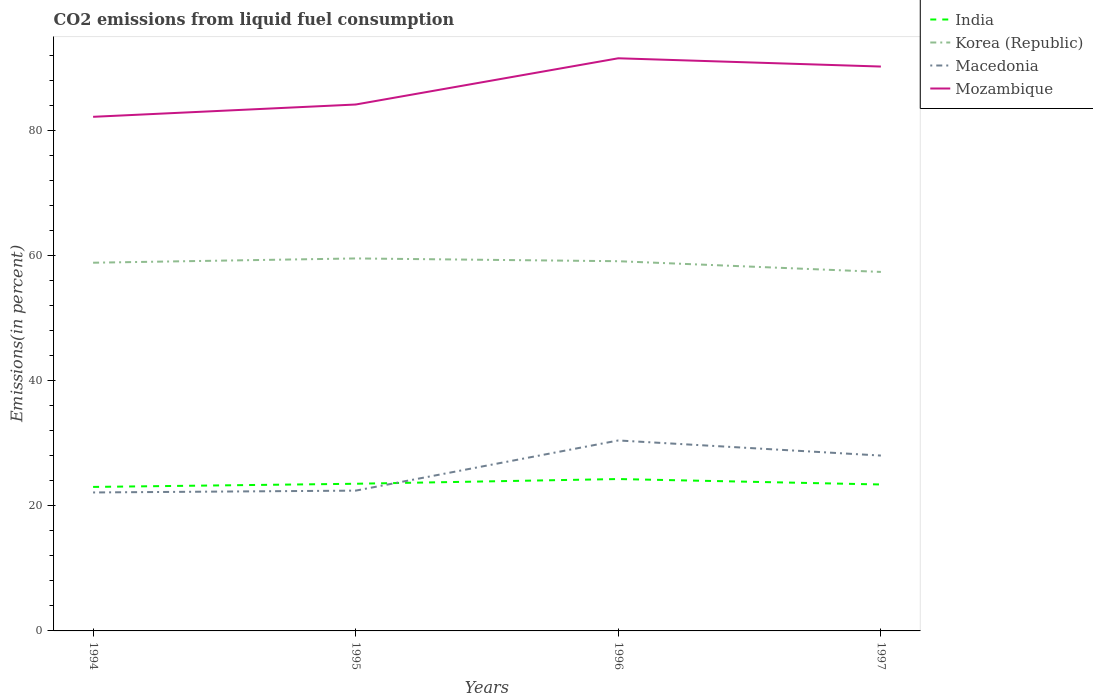Does the line corresponding to Macedonia intersect with the line corresponding to Korea (Republic)?
Offer a very short reply. No. Across all years, what is the maximum total CO2 emitted in Korea (Republic)?
Offer a very short reply. 57.39. What is the total total CO2 emitted in India in the graph?
Offer a terse response. -1.26. What is the difference between the highest and the second highest total CO2 emitted in Mozambique?
Offer a very short reply. 9.36. How many lines are there?
Keep it short and to the point. 4. Where does the legend appear in the graph?
Provide a short and direct response. Top right. What is the title of the graph?
Your answer should be very brief. CO2 emissions from liquid fuel consumption. What is the label or title of the X-axis?
Provide a succinct answer. Years. What is the label or title of the Y-axis?
Provide a succinct answer. Emissions(in percent). What is the Emissions(in percent) in India in 1994?
Provide a succinct answer. 23.02. What is the Emissions(in percent) in Korea (Republic) in 1994?
Offer a very short reply. 58.87. What is the Emissions(in percent) of Macedonia in 1994?
Offer a very short reply. 22.14. What is the Emissions(in percent) of Mozambique in 1994?
Your response must be concise. 82.19. What is the Emissions(in percent) of India in 1995?
Make the answer very short. 23.53. What is the Emissions(in percent) in Korea (Republic) in 1995?
Make the answer very short. 59.55. What is the Emissions(in percent) in Macedonia in 1995?
Your response must be concise. 22.43. What is the Emissions(in percent) of Mozambique in 1995?
Provide a succinct answer. 84.16. What is the Emissions(in percent) in India in 1996?
Your answer should be compact. 24.28. What is the Emissions(in percent) of Korea (Republic) in 1996?
Your answer should be compact. 59.11. What is the Emissions(in percent) in Macedonia in 1996?
Your response must be concise. 30.45. What is the Emissions(in percent) of Mozambique in 1996?
Keep it short and to the point. 91.55. What is the Emissions(in percent) in India in 1997?
Make the answer very short. 23.41. What is the Emissions(in percent) of Korea (Republic) in 1997?
Your answer should be very brief. 57.39. What is the Emissions(in percent) of Macedonia in 1997?
Ensure brevity in your answer.  28.03. What is the Emissions(in percent) in Mozambique in 1997?
Give a very brief answer. 90.23. Across all years, what is the maximum Emissions(in percent) in India?
Your response must be concise. 24.28. Across all years, what is the maximum Emissions(in percent) in Korea (Republic)?
Your answer should be very brief. 59.55. Across all years, what is the maximum Emissions(in percent) of Macedonia?
Your answer should be very brief. 30.45. Across all years, what is the maximum Emissions(in percent) in Mozambique?
Provide a short and direct response. 91.55. Across all years, what is the minimum Emissions(in percent) of India?
Provide a short and direct response. 23.02. Across all years, what is the minimum Emissions(in percent) of Korea (Republic)?
Offer a very short reply. 57.39. Across all years, what is the minimum Emissions(in percent) of Macedonia?
Offer a terse response. 22.14. Across all years, what is the minimum Emissions(in percent) in Mozambique?
Your answer should be compact. 82.19. What is the total Emissions(in percent) of India in the graph?
Make the answer very short. 94.24. What is the total Emissions(in percent) in Korea (Republic) in the graph?
Provide a short and direct response. 234.92. What is the total Emissions(in percent) in Macedonia in the graph?
Your response must be concise. 103.05. What is the total Emissions(in percent) in Mozambique in the graph?
Give a very brief answer. 348.13. What is the difference between the Emissions(in percent) of India in 1994 and that in 1995?
Make the answer very short. -0.51. What is the difference between the Emissions(in percent) in Korea (Republic) in 1994 and that in 1995?
Provide a succinct answer. -0.68. What is the difference between the Emissions(in percent) in Macedonia in 1994 and that in 1995?
Ensure brevity in your answer.  -0.29. What is the difference between the Emissions(in percent) in Mozambique in 1994 and that in 1995?
Keep it short and to the point. -1.97. What is the difference between the Emissions(in percent) in India in 1994 and that in 1996?
Your response must be concise. -1.26. What is the difference between the Emissions(in percent) of Korea (Republic) in 1994 and that in 1996?
Offer a terse response. -0.24. What is the difference between the Emissions(in percent) of Macedonia in 1994 and that in 1996?
Ensure brevity in your answer.  -8.31. What is the difference between the Emissions(in percent) in Mozambique in 1994 and that in 1996?
Offer a very short reply. -9.36. What is the difference between the Emissions(in percent) of India in 1994 and that in 1997?
Offer a terse response. -0.39. What is the difference between the Emissions(in percent) in Korea (Republic) in 1994 and that in 1997?
Your answer should be very brief. 1.47. What is the difference between the Emissions(in percent) of Macedonia in 1994 and that in 1997?
Offer a terse response. -5.9. What is the difference between the Emissions(in percent) of Mozambique in 1994 and that in 1997?
Your response must be concise. -8.04. What is the difference between the Emissions(in percent) in India in 1995 and that in 1996?
Your response must be concise. -0.76. What is the difference between the Emissions(in percent) in Korea (Republic) in 1995 and that in 1996?
Your answer should be compact. 0.44. What is the difference between the Emissions(in percent) of Macedonia in 1995 and that in 1996?
Your answer should be compact. -8.02. What is the difference between the Emissions(in percent) of Mozambique in 1995 and that in 1996?
Offer a terse response. -7.39. What is the difference between the Emissions(in percent) of India in 1995 and that in 1997?
Ensure brevity in your answer.  0.12. What is the difference between the Emissions(in percent) of Korea (Republic) in 1995 and that in 1997?
Keep it short and to the point. 2.16. What is the difference between the Emissions(in percent) of Macedonia in 1995 and that in 1997?
Provide a succinct answer. -5.61. What is the difference between the Emissions(in percent) of Mozambique in 1995 and that in 1997?
Your answer should be compact. -6.07. What is the difference between the Emissions(in percent) of India in 1996 and that in 1997?
Your answer should be compact. 0.87. What is the difference between the Emissions(in percent) of Korea (Republic) in 1996 and that in 1997?
Offer a very short reply. 1.71. What is the difference between the Emissions(in percent) of Macedonia in 1996 and that in 1997?
Your response must be concise. 2.42. What is the difference between the Emissions(in percent) of Mozambique in 1996 and that in 1997?
Your answer should be very brief. 1.32. What is the difference between the Emissions(in percent) in India in 1994 and the Emissions(in percent) in Korea (Republic) in 1995?
Offer a terse response. -36.53. What is the difference between the Emissions(in percent) of India in 1994 and the Emissions(in percent) of Macedonia in 1995?
Provide a succinct answer. 0.59. What is the difference between the Emissions(in percent) in India in 1994 and the Emissions(in percent) in Mozambique in 1995?
Your answer should be compact. -61.14. What is the difference between the Emissions(in percent) of Korea (Republic) in 1994 and the Emissions(in percent) of Macedonia in 1995?
Offer a very short reply. 36.44. What is the difference between the Emissions(in percent) in Korea (Republic) in 1994 and the Emissions(in percent) in Mozambique in 1995?
Keep it short and to the point. -25.29. What is the difference between the Emissions(in percent) of Macedonia in 1994 and the Emissions(in percent) of Mozambique in 1995?
Keep it short and to the point. -62.02. What is the difference between the Emissions(in percent) of India in 1994 and the Emissions(in percent) of Korea (Republic) in 1996?
Your response must be concise. -36.09. What is the difference between the Emissions(in percent) of India in 1994 and the Emissions(in percent) of Macedonia in 1996?
Your answer should be very brief. -7.43. What is the difference between the Emissions(in percent) in India in 1994 and the Emissions(in percent) in Mozambique in 1996?
Give a very brief answer. -68.53. What is the difference between the Emissions(in percent) in Korea (Republic) in 1994 and the Emissions(in percent) in Macedonia in 1996?
Ensure brevity in your answer.  28.42. What is the difference between the Emissions(in percent) in Korea (Republic) in 1994 and the Emissions(in percent) in Mozambique in 1996?
Make the answer very short. -32.68. What is the difference between the Emissions(in percent) in Macedonia in 1994 and the Emissions(in percent) in Mozambique in 1996?
Keep it short and to the point. -69.41. What is the difference between the Emissions(in percent) in India in 1994 and the Emissions(in percent) in Korea (Republic) in 1997?
Provide a succinct answer. -34.37. What is the difference between the Emissions(in percent) in India in 1994 and the Emissions(in percent) in Macedonia in 1997?
Provide a succinct answer. -5.01. What is the difference between the Emissions(in percent) of India in 1994 and the Emissions(in percent) of Mozambique in 1997?
Offer a terse response. -67.21. What is the difference between the Emissions(in percent) in Korea (Republic) in 1994 and the Emissions(in percent) in Macedonia in 1997?
Your answer should be compact. 30.83. What is the difference between the Emissions(in percent) in Korea (Republic) in 1994 and the Emissions(in percent) in Mozambique in 1997?
Keep it short and to the point. -31.36. What is the difference between the Emissions(in percent) of Macedonia in 1994 and the Emissions(in percent) of Mozambique in 1997?
Offer a terse response. -68.09. What is the difference between the Emissions(in percent) of India in 1995 and the Emissions(in percent) of Korea (Republic) in 1996?
Your answer should be compact. -35.58. What is the difference between the Emissions(in percent) in India in 1995 and the Emissions(in percent) in Macedonia in 1996?
Make the answer very short. -6.92. What is the difference between the Emissions(in percent) of India in 1995 and the Emissions(in percent) of Mozambique in 1996?
Offer a terse response. -68.02. What is the difference between the Emissions(in percent) in Korea (Republic) in 1995 and the Emissions(in percent) in Macedonia in 1996?
Provide a short and direct response. 29.1. What is the difference between the Emissions(in percent) in Korea (Republic) in 1995 and the Emissions(in percent) in Mozambique in 1996?
Give a very brief answer. -32. What is the difference between the Emissions(in percent) in Macedonia in 1995 and the Emissions(in percent) in Mozambique in 1996?
Give a very brief answer. -69.12. What is the difference between the Emissions(in percent) in India in 1995 and the Emissions(in percent) in Korea (Republic) in 1997?
Your answer should be compact. -33.87. What is the difference between the Emissions(in percent) of India in 1995 and the Emissions(in percent) of Macedonia in 1997?
Provide a succinct answer. -4.51. What is the difference between the Emissions(in percent) in India in 1995 and the Emissions(in percent) in Mozambique in 1997?
Offer a very short reply. -66.7. What is the difference between the Emissions(in percent) of Korea (Republic) in 1995 and the Emissions(in percent) of Macedonia in 1997?
Provide a succinct answer. 31.52. What is the difference between the Emissions(in percent) of Korea (Republic) in 1995 and the Emissions(in percent) of Mozambique in 1997?
Make the answer very short. -30.68. What is the difference between the Emissions(in percent) of Macedonia in 1995 and the Emissions(in percent) of Mozambique in 1997?
Your answer should be compact. -67.8. What is the difference between the Emissions(in percent) in India in 1996 and the Emissions(in percent) in Korea (Republic) in 1997?
Ensure brevity in your answer.  -33.11. What is the difference between the Emissions(in percent) in India in 1996 and the Emissions(in percent) in Macedonia in 1997?
Your answer should be very brief. -3.75. What is the difference between the Emissions(in percent) in India in 1996 and the Emissions(in percent) in Mozambique in 1997?
Ensure brevity in your answer.  -65.95. What is the difference between the Emissions(in percent) of Korea (Republic) in 1996 and the Emissions(in percent) of Macedonia in 1997?
Your answer should be compact. 31.07. What is the difference between the Emissions(in percent) of Korea (Republic) in 1996 and the Emissions(in percent) of Mozambique in 1997?
Keep it short and to the point. -31.12. What is the difference between the Emissions(in percent) of Macedonia in 1996 and the Emissions(in percent) of Mozambique in 1997?
Make the answer very short. -59.78. What is the average Emissions(in percent) of India per year?
Give a very brief answer. 23.56. What is the average Emissions(in percent) of Korea (Republic) per year?
Make the answer very short. 58.73. What is the average Emissions(in percent) of Macedonia per year?
Give a very brief answer. 25.76. What is the average Emissions(in percent) in Mozambique per year?
Keep it short and to the point. 87.03. In the year 1994, what is the difference between the Emissions(in percent) of India and Emissions(in percent) of Korea (Republic)?
Keep it short and to the point. -35.84. In the year 1994, what is the difference between the Emissions(in percent) of India and Emissions(in percent) of Macedonia?
Offer a terse response. 0.88. In the year 1994, what is the difference between the Emissions(in percent) of India and Emissions(in percent) of Mozambique?
Offer a terse response. -59.17. In the year 1994, what is the difference between the Emissions(in percent) in Korea (Republic) and Emissions(in percent) in Macedonia?
Offer a terse response. 36.73. In the year 1994, what is the difference between the Emissions(in percent) in Korea (Republic) and Emissions(in percent) in Mozambique?
Your answer should be very brief. -23.33. In the year 1994, what is the difference between the Emissions(in percent) of Macedonia and Emissions(in percent) of Mozambique?
Make the answer very short. -60.06. In the year 1995, what is the difference between the Emissions(in percent) of India and Emissions(in percent) of Korea (Republic)?
Provide a succinct answer. -36.02. In the year 1995, what is the difference between the Emissions(in percent) of India and Emissions(in percent) of Macedonia?
Your answer should be very brief. 1.1. In the year 1995, what is the difference between the Emissions(in percent) in India and Emissions(in percent) in Mozambique?
Provide a succinct answer. -60.63. In the year 1995, what is the difference between the Emissions(in percent) in Korea (Republic) and Emissions(in percent) in Macedonia?
Your response must be concise. 37.12. In the year 1995, what is the difference between the Emissions(in percent) in Korea (Republic) and Emissions(in percent) in Mozambique?
Your answer should be compact. -24.61. In the year 1995, what is the difference between the Emissions(in percent) of Macedonia and Emissions(in percent) of Mozambique?
Make the answer very short. -61.73. In the year 1996, what is the difference between the Emissions(in percent) of India and Emissions(in percent) of Korea (Republic)?
Offer a very short reply. -34.83. In the year 1996, what is the difference between the Emissions(in percent) in India and Emissions(in percent) in Macedonia?
Your response must be concise. -6.17. In the year 1996, what is the difference between the Emissions(in percent) in India and Emissions(in percent) in Mozambique?
Give a very brief answer. -67.27. In the year 1996, what is the difference between the Emissions(in percent) in Korea (Republic) and Emissions(in percent) in Macedonia?
Provide a succinct answer. 28.66. In the year 1996, what is the difference between the Emissions(in percent) of Korea (Republic) and Emissions(in percent) of Mozambique?
Your answer should be very brief. -32.44. In the year 1996, what is the difference between the Emissions(in percent) of Macedonia and Emissions(in percent) of Mozambique?
Provide a short and direct response. -61.1. In the year 1997, what is the difference between the Emissions(in percent) of India and Emissions(in percent) of Korea (Republic)?
Your answer should be compact. -33.98. In the year 1997, what is the difference between the Emissions(in percent) of India and Emissions(in percent) of Macedonia?
Your response must be concise. -4.62. In the year 1997, what is the difference between the Emissions(in percent) of India and Emissions(in percent) of Mozambique?
Offer a terse response. -66.82. In the year 1997, what is the difference between the Emissions(in percent) in Korea (Republic) and Emissions(in percent) in Macedonia?
Offer a terse response. 29.36. In the year 1997, what is the difference between the Emissions(in percent) in Korea (Republic) and Emissions(in percent) in Mozambique?
Ensure brevity in your answer.  -32.83. In the year 1997, what is the difference between the Emissions(in percent) in Macedonia and Emissions(in percent) in Mozambique?
Offer a terse response. -62.19. What is the ratio of the Emissions(in percent) of India in 1994 to that in 1995?
Your answer should be compact. 0.98. What is the ratio of the Emissions(in percent) of Mozambique in 1994 to that in 1995?
Provide a succinct answer. 0.98. What is the ratio of the Emissions(in percent) of India in 1994 to that in 1996?
Offer a very short reply. 0.95. What is the ratio of the Emissions(in percent) of Korea (Republic) in 1994 to that in 1996?
Provide a short and direct response. 1. What is the ratio of the Emissions(in percent) of Macedonia in 1994 to that in 1996?
Give a very brief answer. 0.73. What is the ratio of the Emissions(in percent) in Mozambique in 1994 to that in 1996?
Ensure brevity in your answer.  0.9. What is the ratio of the Emissions(in percent) of India in 1994 to that in 1997?
Provide a short and direct response. 0.98. What is the ratio of the Emissions(in percent) in Korea (Republic) in 1994 to that in 1997?
Your answer should be very brief. 1.03. What is the ratio of the Emissions(in percent) of Macedonia in 1994 to that in 1997?
Ensure brevity in your answer.  0.79. What is the ratio of the Emissions(in percent) of Mozambique in 1994 to that in 1997?
Provide a short and direct response. 0.91. What is the ratio of the Emissions(in percent) of India in 1995 to that in 1996?
Your answer should be compact. 0.97. What is the ratio of the Emissions(in percent) in Korea (Republic) in 1995 to that in 1996?
Your answer should be compact. 1.01. What is the ratio of the Emissions(in percent) in Macedonia in 1995 to that in 1996?
Make the answer very short. 0.74. What is the ratio of the Emissions(in percent) of Mozambique in 1995 to that in 1996?
Offer a very short reply. 0.92. What is the ratio of the Emissions(in percent) in Korea (Republic) in 1995 to that in 1997?
Your answer should be very brief. 1.04. What is the ratio of the Emissions(in percent) in Macedonia in 1995 to that in 1997?
Provide a succinct answer. 0.8. What is the ratio of the Emissions(in percent) of Mozambique in 1995 to that in 1997?
Provide a succinct answer. 0.93. What is the ratio of the Emissions(in percent) of India in 1996 to that in 1997?
Ensure brevity in your answer.  1.04. What is the ratio of the Emissions(in percent) in Korea (Republic) in 1996 to that in 1997?
Your response must be concise. 1.03. What is the ratio of the Emissions(in percent) in Macedonia in 1996 to that in 1997?
Your response must be concise. 1.09. What is the ratio of the Emissions(in percent) in Mozambique in 1996 to that in 1997?
Offer a very short reply. 1.01. What is the difference between the highest and the second highest Emissions(in percent) of India?
Offer a very short reply. 0.76. What is the difference between the highest and the second highest Emissions(in percent) in Korea (Republic)?
Make the answer very short. 0.44. What is the difference between the highest and the second highest Emissions(in percent) of Macedonia?
Provide a succinct answer. 2.42. What is the difference between the highest and the second highest Emissions(in percent) of Mozambique?
Your response must be concise. 1.32. What is the difference between the highest and the lowest Emissions(in percent) in India?
Provide a short and direct response. 1.26. What is the difference between the highest and the lowest Emissions(in percent) in Korea (Republic)?
Your answer should be compact. 2.16. What is the difference between the highest and the lowest Emissions(in percent) of Macedonia?
Provide a short and direct response. 8.31. What is the difference between the highest and the lowest Emissions(in percent) of Mozambique?
Ensure brevity in your answer.  9.36. 